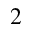Convert formula to latex. <formula><loc_0><loc_0><loc_500><loc_500>_ { 2 }</formula> 